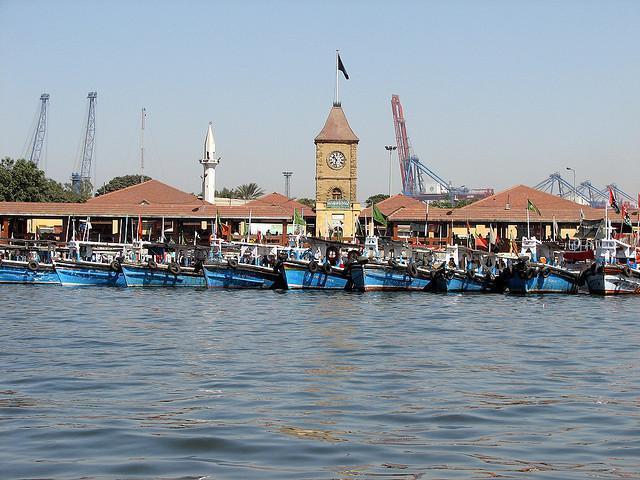How many boats can you count?
Give a very brief answer. 9. How many boats are there?
Give a very brief answer. 7. 